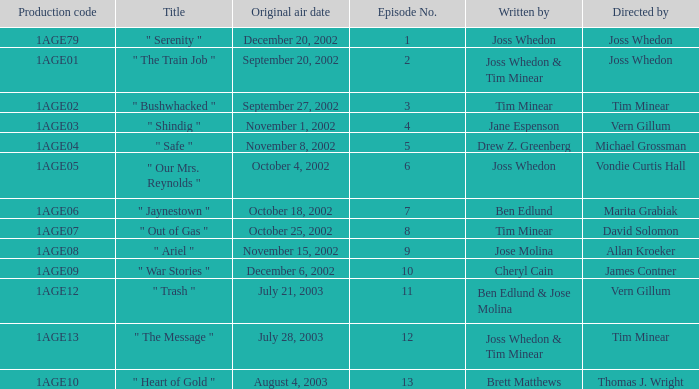Who directed episode number 3? Tim Minear. 